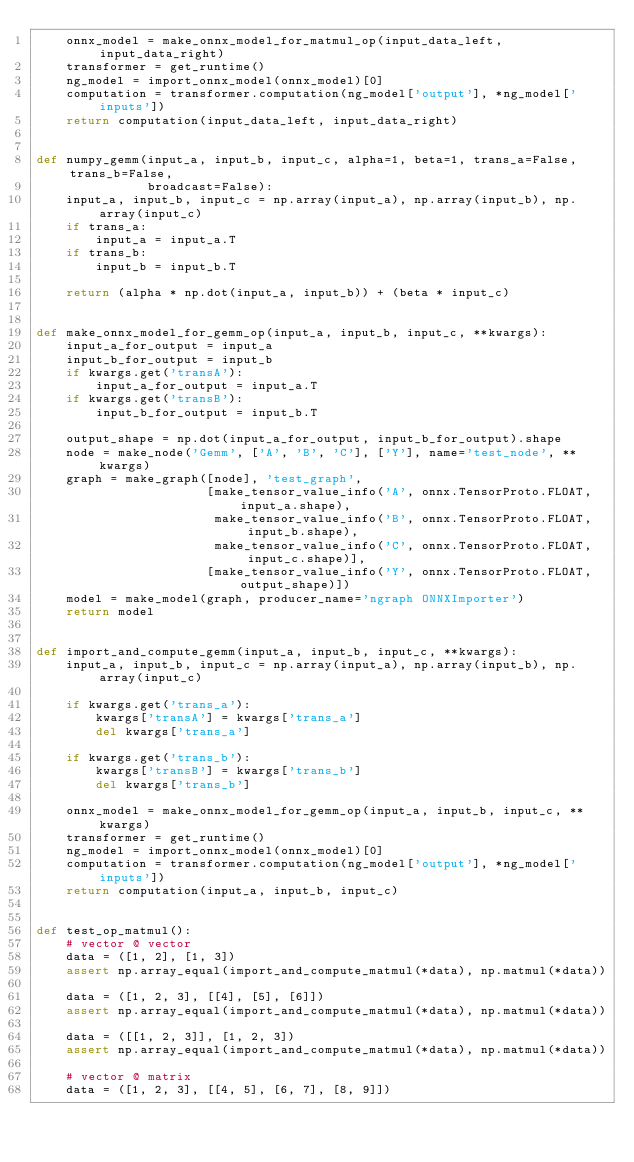Convert code to text. <code><loc_0><loc_0><loc_500><loc_500><_Python_>    onnx_model = make_onnx_model_for_matmul_op(input_data_left, input_data_right)
    transformer = get_runtime()
    ng_model = import_onnx_model(onnx_model)[0]
    computation = transformer.computation(ng_model['output'], *ng_model['inputs'])
    return computation(input_data_left, input_data_right)


def numpy_gemm(input_a, input_b, input_c, alpha=1, beta=1, trans_a=False, trans_b=False,
               broadcast=False):
    input_a, input_b, input_c = np.array(input_a), np.array(input_b), np.array(input_c)
    if trans_a:
        input_a = input_a.T
    if trans_b:
        input_b = input_b.T

    return (alpha * np.dot(input_a, input_b)) + (beta * input_c)


def make_onnx_model_for_gemm_op(input_a, input_b, input_c, **kwargs):
    input_a_for_output = input_a
    input_b_for_output = input_b
    if kwargs.get('transA'):
        input_a_for_output = input_a.T
    if kwargs.get('transB'):
        input_b_for_output = input_b.T

    output_shape = np.dot(input_a_for_output, input_b_for_output).shape
    node = make_node('Gemm', ['A', 'B', 'C'], ['Y'], name='test_node', **kwargs)
    graph = make_graph([node], 'test_graph',
                       [make_tensor_value_info('A', onnx.TensorProto.FLOAT, input_a.shape),
                        make_tensor_value_info('B', onnx.TensorProto.FLOAT, input_b.shape),
                        make_tensor_value_info('C', onnx.TensorProto.FLOAT, input_c.shape)],
                       [make_tensor_value_info('Y', onnx.TensorProto.FLOAT, output_shape)])
    model = make_model(graph, producer_name='ngraph ONNXImporter')
    return model


def import_and_compute_gemm(input_a, input_b, input_c, **kwargs):
    input_a, input_b, input_c = np.array(input_a), np.array(input_b), np.array(input_c)

    if kwargs.get('trans_a'):
        kwargs['transA'] = kwargs['trans_a']
        del kwargs['trans_a']

    if kwargs.get('trans_b'):
        kwargs['transB'] = kwargs['trans_b']
        del kwargs['trans_b']

    onnx_model = make_onnx_model_for_gemm_op(input_a, input_b, input_c, **kwargs)
    transformer = get_runtime()
    ng_model = import_onnx_model(onnx_model)[0]
    computation = transformer.computation(ng_model['output'], *ng_model['inputs'])
    return computation(input_a, input_b, input_c)


def test_op_matmul():
    # vector @ vector
    data = ([1, 2], [1, 3])
    assert np.array_equal(import_and_compute_matmul(*data), np.matmul(*data))

    data = ([1, 2, 3], [[4], [5], [6]])
    assert np.array_equal(import_and_compute_matmul(*data), np.matmul(*data))

    data = ([[1, 2, 3]], [1, 2, 3])
    assert np.array_equal(import_and_compute_matmul(*data), np.matmul(*data))

    # vector @ matrix
    data = ([1, 2, 3], [[4, 5], [6, 7], [8, 9]])</code> 